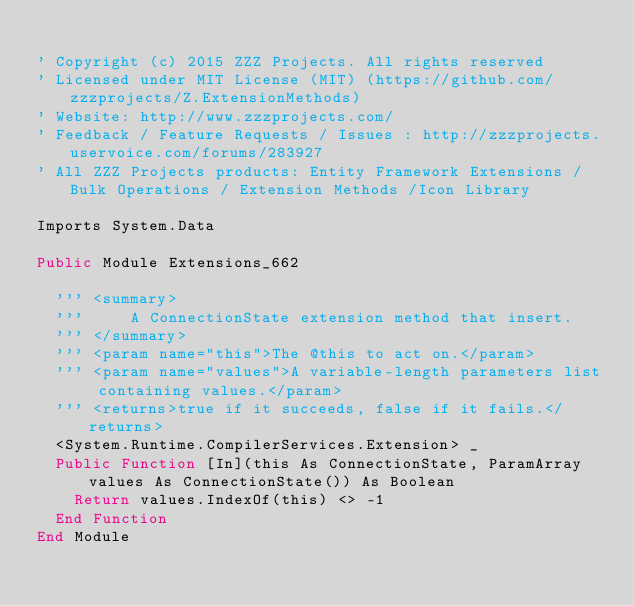Convert code to text. <code><loc_0><loc_0><loc_500><loc_500><_VisualBasic_>
' Copyright (c) 2015 ZZZ Projects. All rights reserved
' Licensed under MIT License (MIT) (https://github.com/zzzprojects/Z.ExtensionMethods)
' Website: http://www.zzzprojects.com/
' Feedback / Feature Requests / Issues : http://zzzprojects.uservoice.com/forums/283927
' All ZZZ Projects products: Entity Framework Extensions / Bulk Operations / Extension Methods /Icon Library

Imports System.Data

Public Module Extensions_662

	''' <summary>
	'''     A ConnectionState extension method that insert.
	''' </summary>
	''' <param name="this">The @this to act on.</param>
	''' <param name="values">A variable-length parameters list containing values.</param>
	''' <returns>true if it succeeds, false if it fails.</returns>
	<System.Runtime.CompilerServices.Extension> _
	Public Function [In](this As ConnectionState, ParamArray values As ConnectionState()) As Boolean
		Return values.IndexOf(this) <> -1
	End Function
End Module


</code> 